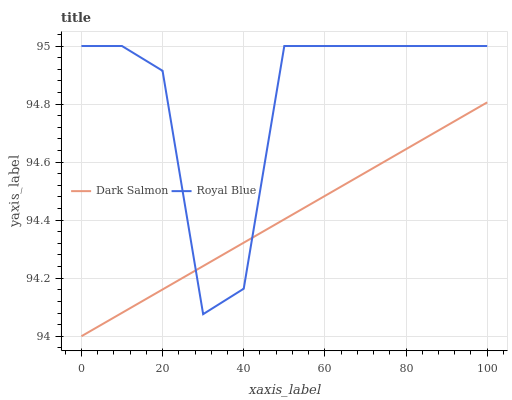Does Dark Salmon have the minimum area under the curve?
Answer yes or no. Yes. Does Royal Blue have the maximum area under the curve?
Answer yes or no. Yes. Does Dark Salmon have the maximum area under the curve?
Answer yes or no. No. Is Dark Salmon the smoothest?
Answer yes or no. Yes. Is Royal Blue the roughest?
Answer yes or no. Yes. Is Dark Salmon the roughest?
Answer yes or no. No. Does Royal Blue have the highest value?
Answer yes or no. Yes. Does Dark Salmon have the highest value?
Answer yes or no. No. Does Royal Blue intersect Dark Salmon?
Answer yes or no. Yes. Is Royal Blue less than Dark Salmon?
Answer yes or no. No. Is Royal Blue greater than Dark Salmon?
Answer yes or no. No. 